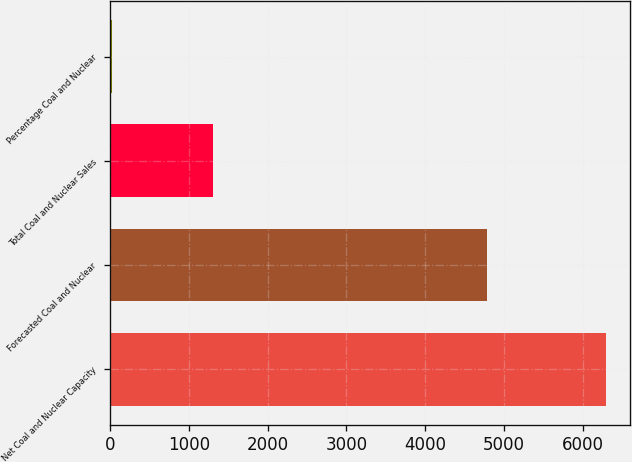<chart> <loc_0><loc_0><loc_500><loc_500><bar_chart><fcel>Net Coal and Nuclear Capacity<fcel>Forecasted Coal and Nuclear<fcel>Total Coal and Nuclear Sales<fcel>Percentage Coal and Nuclear<nl><fcel>6290<fcel>4789<fcel>1300<fcel>27<nl></chart> 